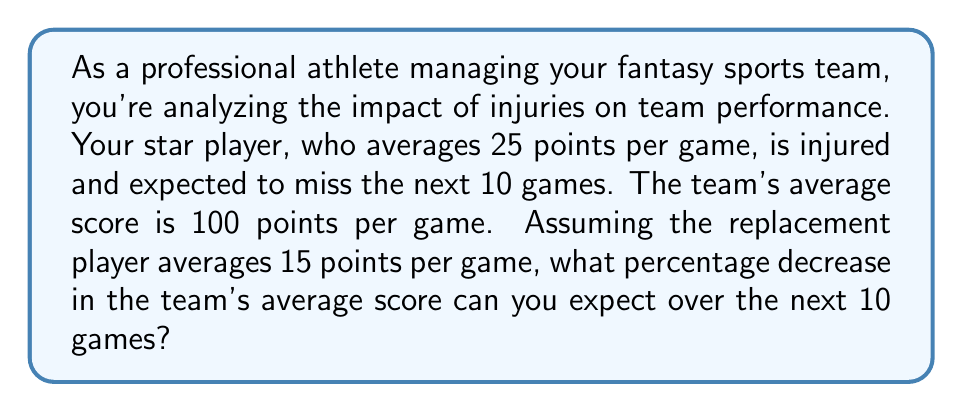Can you answer this question? Let's approach this step-by-step:

1. Calculate the team's current total points per game:
   $100$ points

2. Calculate the points contributed by the star player:
   $25$ points

3. Calculate the points that will be contributed by the replacement player:
   $15$ points

4. Calculate the new team total with the replacement player:
   $100 - 25 + 15 = 90$ points

5. Calculate the percentage decrease:
   Percentage decrease = $\frac{\text{Decrease}}{\text{Original}} \times 100\%$
   
   $$\text{Percentage decrease} = \frac{100 - 90}{100} \times 100\% = \frac{10}{100} \times 100\% = 10\%$$

Therefore, you can expect a 10% decrease in the team's average score over the next 10 games.
Answer: 10% 